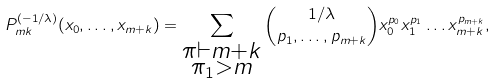Convert formula to latex. <formula><loc_0><loc_0><loc_500><loc_500>P _ { m k } ^ { ( - 1 / \lambda ) } ( x _ { 0 } , \dots , x _ { m + k } ) = \sum _ { \substack { \pi \vdash m + k \\ \pi _ { 1 } > m } } \binom { 1 / \lambda } { p _ { 1 } , \dots , p _ { m + k } } x _ { 0 } ^ { p _ { 0 } } x _ { 1 } ^ { p _ { 1 } } \dots x _ { m + k } ^ { p _ { m + k } } ,</formula> 